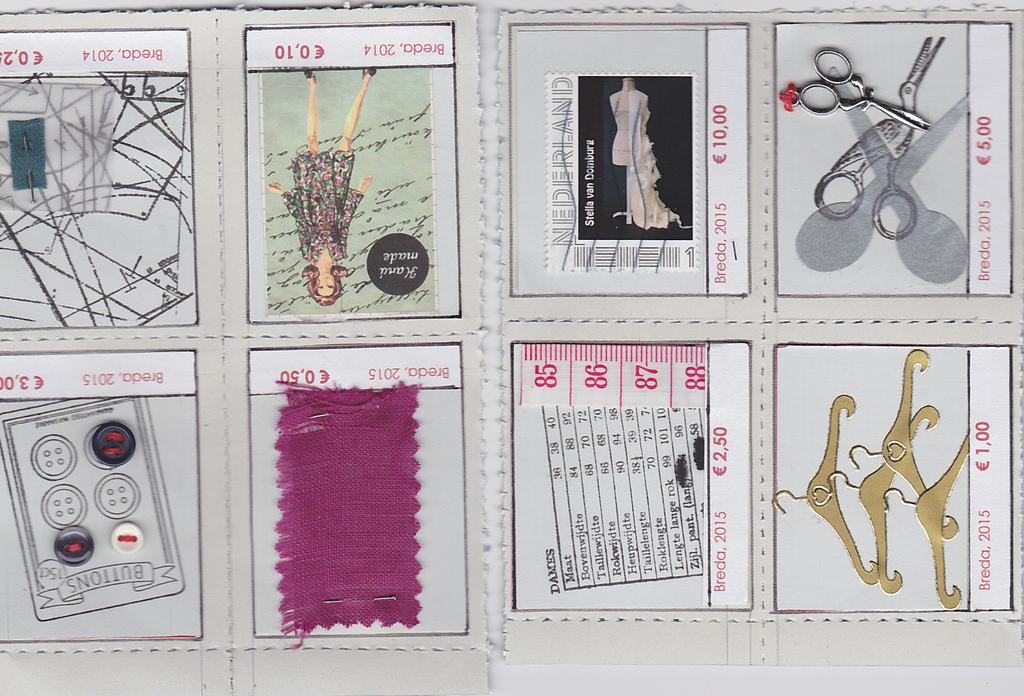What objects are present in the image? There are postage stamps in the image. Where are the postage stamps located? The postage stamps are placed on a surface. How quiet is the postage stamp in the image? Postage stamps do not have a level of quietness, as they are inanimate objects. 